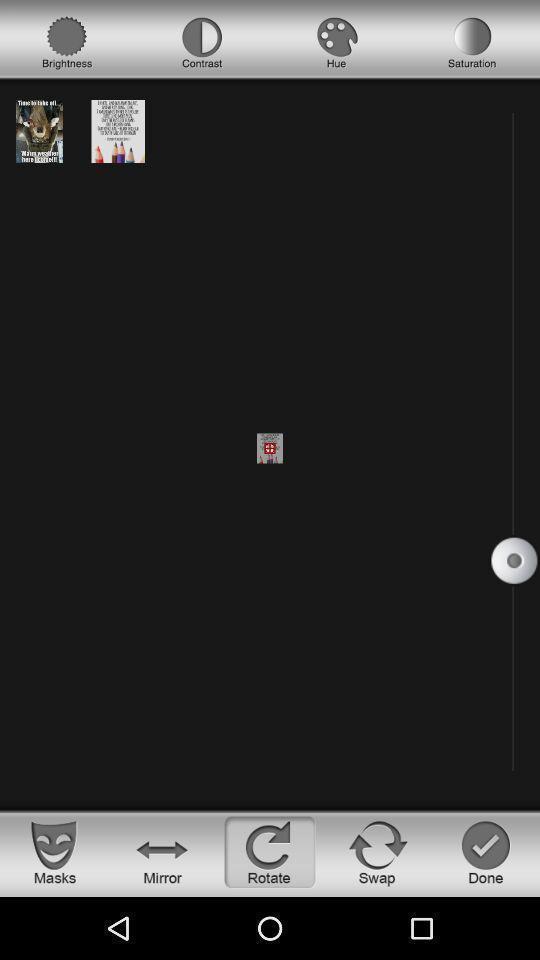Describe the visual elements of this screenshot. Page for editing pics of an editing app. 